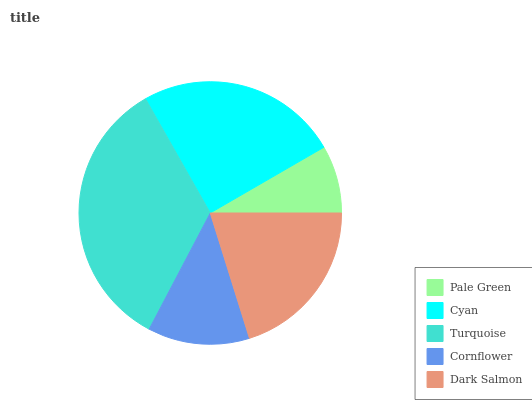Is Pale Green the minimum?
Answer yes or no. Yes. Is Turquoise the maximum?
Answer yes or no. Yes. Is Cyan the minimum?
Answer yes or no. No. Is Cyan the maximum?
Answer yes or no. No. Is Cyan greater than Pale Green?
Answer yes or no. Yes. Is Pale Green less than Cyan?
Answer yes or no. Yes. Is Pale Green greater than Cyan?
Answer yes or no. No. Is Cyan less than Pale Green?
Answer yes or no. No. Is Dark Salmon the high median?
Answer yes or no. Yes. Is Dark Salmon the low median?
Answer yes or no. Yes. Is Pale Green the high median?
Answer yes or no. No. Is Turquoise the low median?
Answer yes or no. No. 